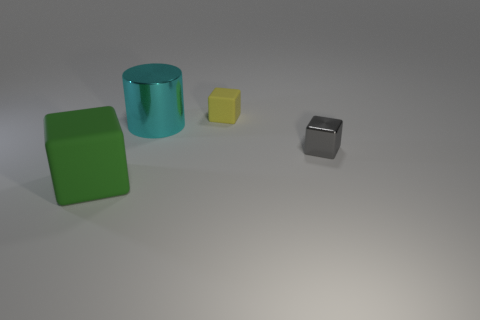What is the shape of the small gray thing that is the same material as the cyan cylinder? cube 